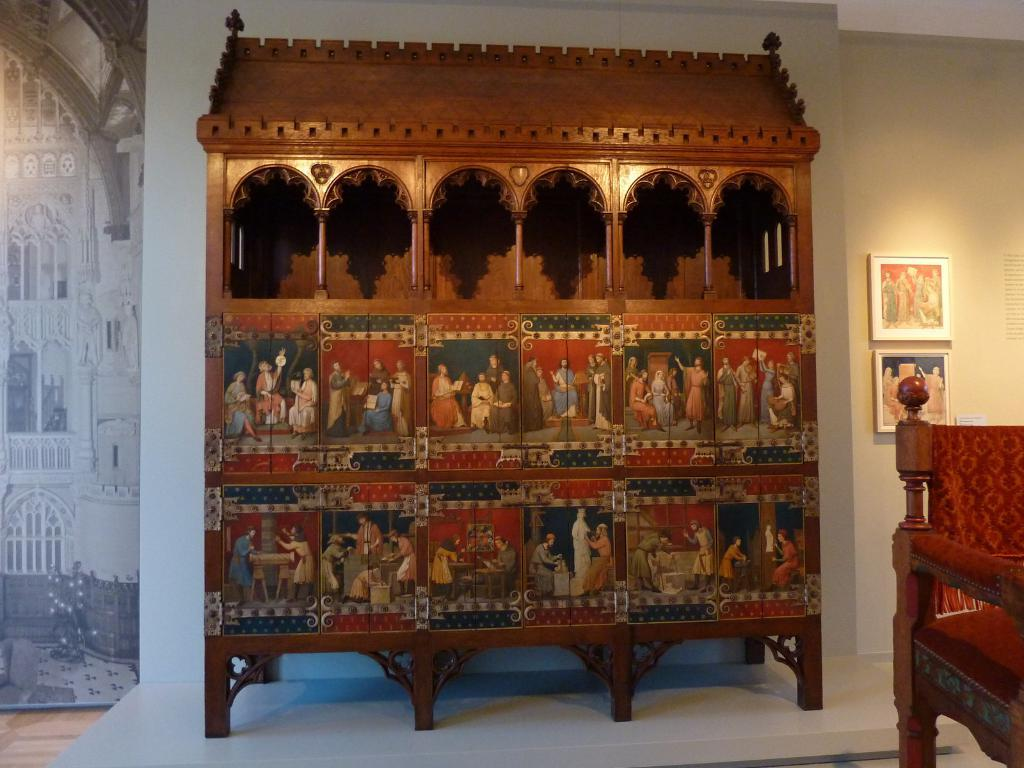What type of furniture is present in the image? There is a wooden rack and a wooden chair in the image. What can be seen on the wall in the image? There are photo frames on the wall in the image. What is the purpose of the joke in the image? There is no joke present in the image; it only features a wooden rack, a wooden chair, and photo frames on the wall. 